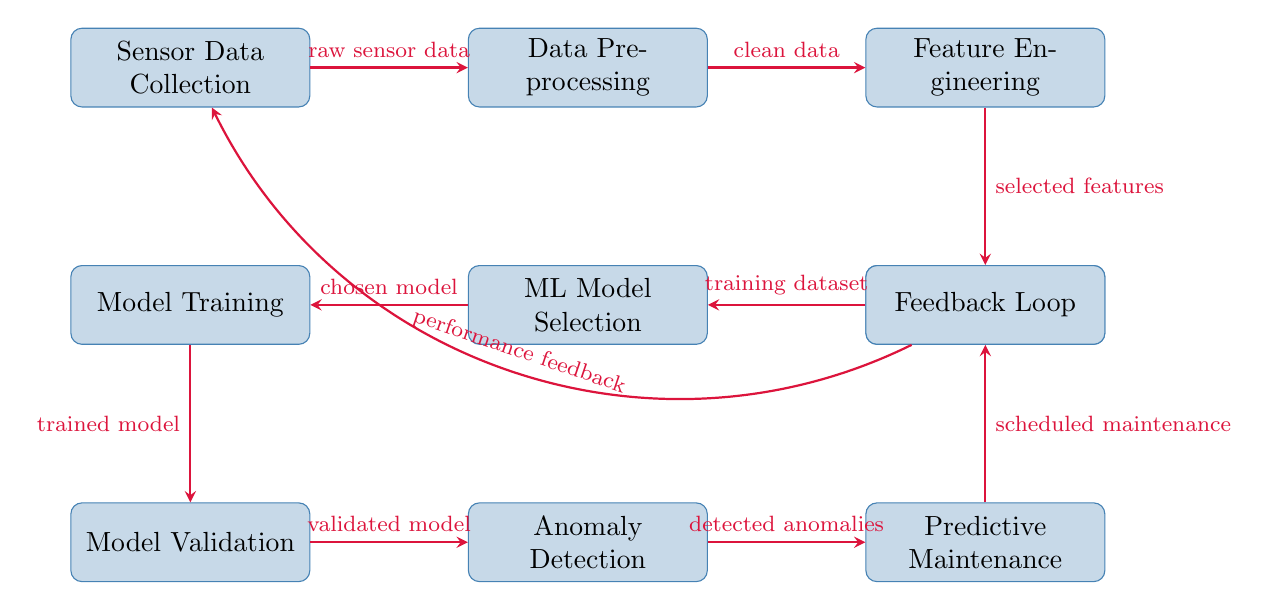What is the first step in the diagram? The first step indicated in the diagram is "Sensor Data Collection," which is the starting point for the process of predictive maintenance using machine learning.
Answer: Sensor Data Collection How many processes are represented in the diagram? The diagram contains a total of 9 processes, ranging from "Sensor Data Collection" to "Feedback Loop."
Answer: 9 What does the output of the "Anomaly Detection" process lead to? The output of the "Anomaly Detection" process leads to "Predictive Maintenance," as indicated by the arrow connecting these two nodes.
Answer: Predictive Maintenance Which process comes before "Model Validation"? The process that comes before "Model Validation" is "Model Training," as shown by the directed arrow leading into "Model Validation."
Answer: Model Training What type of data flows from "Data Preprocessing" to "Feature Engineering"? The type of data that flows from "Data Preprocessing" to "Feature Engineering" is "clean data," as labeled on the corresponding arrow.
Answer: clean data How does the "Feedback Loop" affect the entire process? The "Feedback Loop" sends "performance feedback" back to "Sensor Data Collection," creating a continuous cycle of improvement in the predictive maintenance process. This indicates that the model can adapt based on collected performance data.
Answer: performance feedback What comes after "Training Data" in the sequence? After "Training Data," the next step is "ML Model Selection," which is indicated as the following process in the flow.
Answer: ML Model Selection Which process is responsible for selecting the features? The process responsible for selecting the features is "Feature Engineering," which is a key step where selected features are derived from cleaned data.
Answer: Feature Engineering What type of model is produced by the "Model Training" process? The model produced by the "Model Training" process is referred to as "trained model," as specified on the arrow indicating the output from this process.
Answer: trained model 